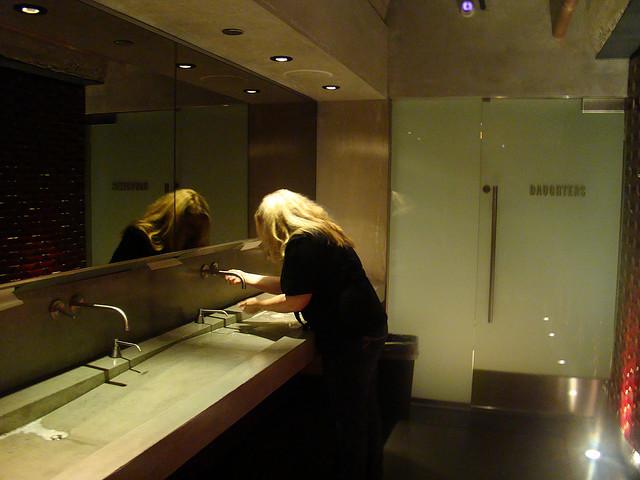What is the woman trying to do with her right hand?
Short answer required. Get soap. What color is her hair?
Quick response, please. Blonde. Is the woman a cleaning lady?
Write a very short answer. No. 